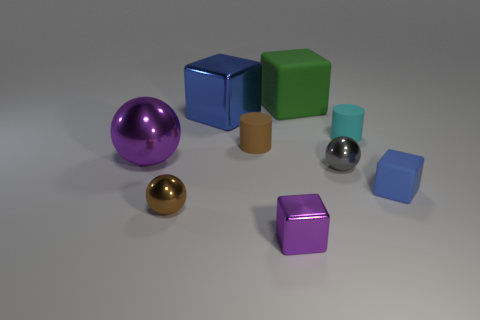There is a brown cylinder; does it have the same size as the blue thing that is left of the green matte object?
Make the answer very short. No. Do the cyan thing and the purple metallic ball have the same size?
Give a very brief answer. No. What number of tiny objects are blue spheres or brown metallic balls?
Provide a short and direct response. 1. How many brown metallic things are right of the tiny purple thing?
Give a very brief answer. 0. Is the number of tiny cyan matte cylinders that are left of the large green object greater than the number of blue things?
Give a very brief answer. No. There is a small purple thing that is made of the same material as the tiny gray object; what is its shape?
Provide a short and direct response. Cube. There is a cylinder behind the small cylinder that is to the left of the green matte cube; what color is it?
Your response must be concise. Cyan. Do the big purple metallic object and the gray object have the same shape?
Keep it short and to the point. Yes. There is a brown thing that is the same shape as the tiny cyan object; what material is it?
Make the answer very short. Rubber. Are there any spheres that are on the left side of the blue block that is behind the large shiny thing that is left of the big blue metal object?
Your answer should be very brief. Yes. 